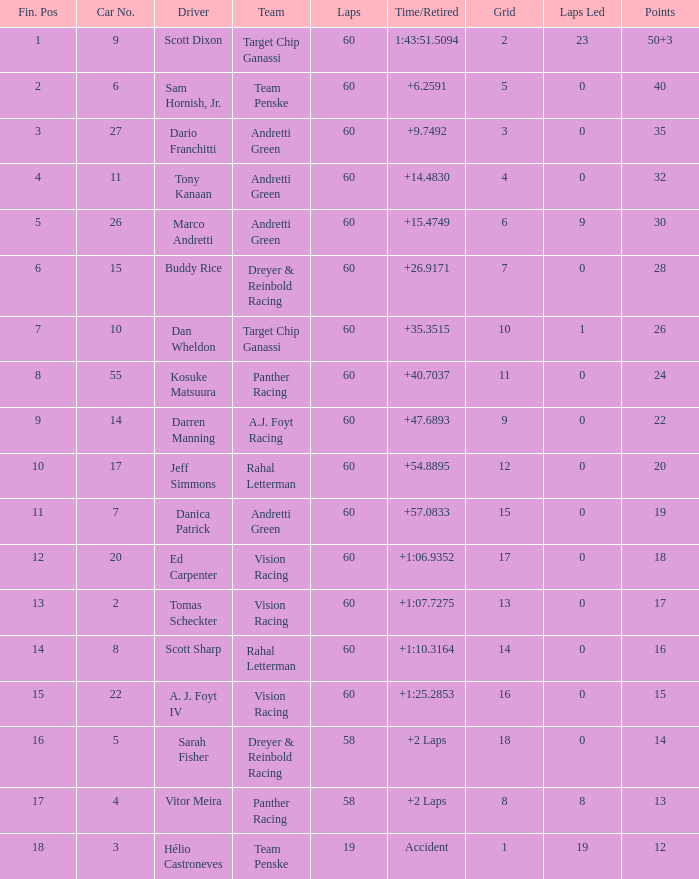Identify the squad of darren manning. A.J. Foyt Racing. 